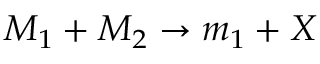<formula> <loc_0><loc_0><loc_500><loc_500>M _ { 1 } + M _ { 2 } \rightarrow m _ { 1 } + X</formula> 